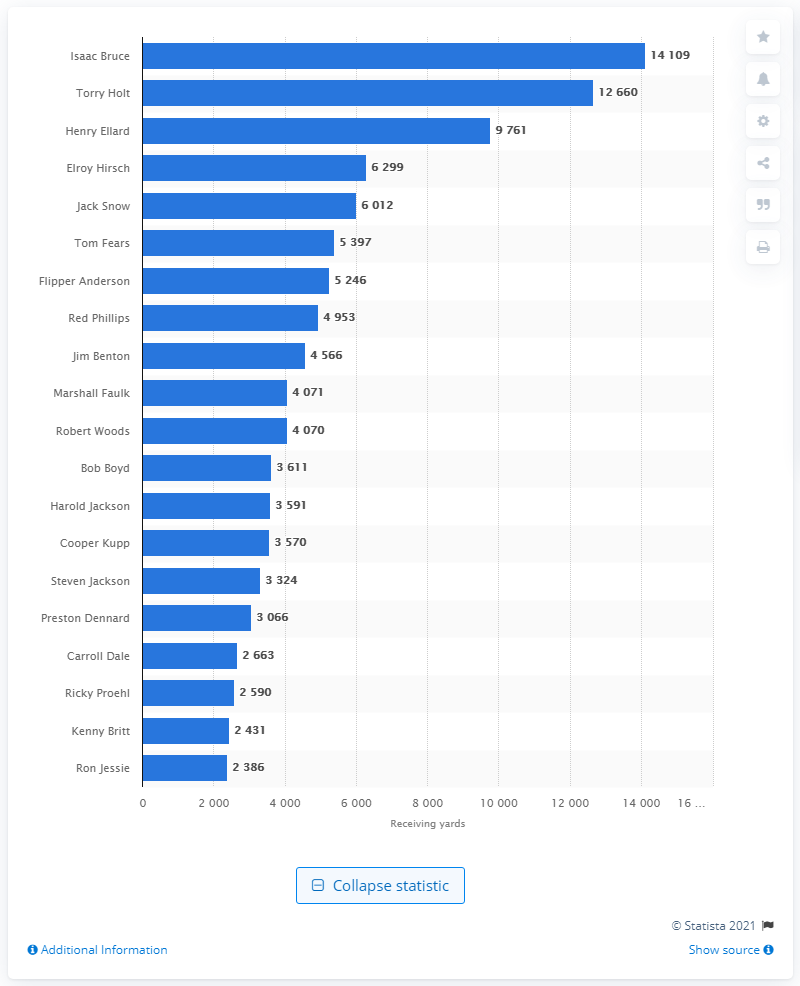Indicate a few pertinent items in this graphic. Isaac Bruce is the all-time career receiving leader for the Los Angeles Rams. 